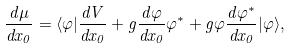<formula> <loc_0><loc_0><loc_500><loc_500>\frac { d \mu } { d x _ { 0 } } = \langle \varphi | \frac { d V } { d x _ { 0 } } + g \frac { d \varphi } { d x _ { 0 } } \varphi ^ { * } + g \varphi \frac { d \varphi ^ { * } } { d x _ { 0 } } | \varphi \rangle ,</formula> 